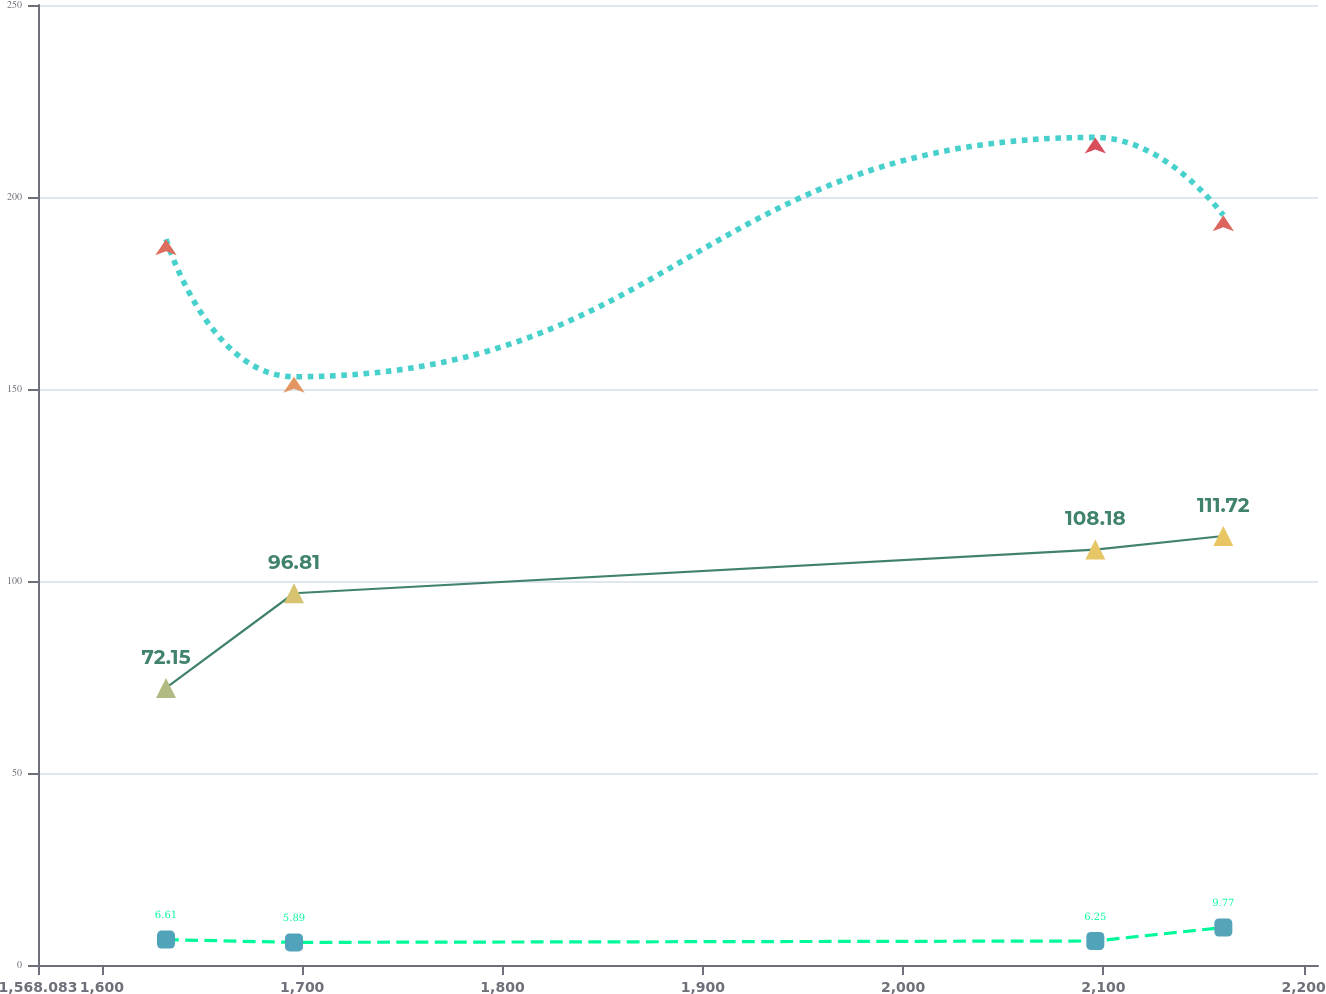Convert chart to OTSL. <chart><loc_0><loc_0><loc_500><loc_500><line_chart><ecel><fcel>Expected federal subsidy payments post retirement benefits<fcel>Postretirement benefits<fcel>Pension benefits<nl><fcel>1631.99<fcel>189.01<fcel>72.15<fcel>6.61<nl><fcel>1695.9<fcel>153.2<fcel>96.81<fcel>5.89<nl><fcel>2095.98<fcel>215.52<fcel>108.18<fcel>6.25<nl><fcel>2159.89<fcel>195.24<fcel>111.72<fcel>9.77<nl><fcel>2271.06<fcel>167.59<fcel>104.64<fcel>9.41<nl></chart> 